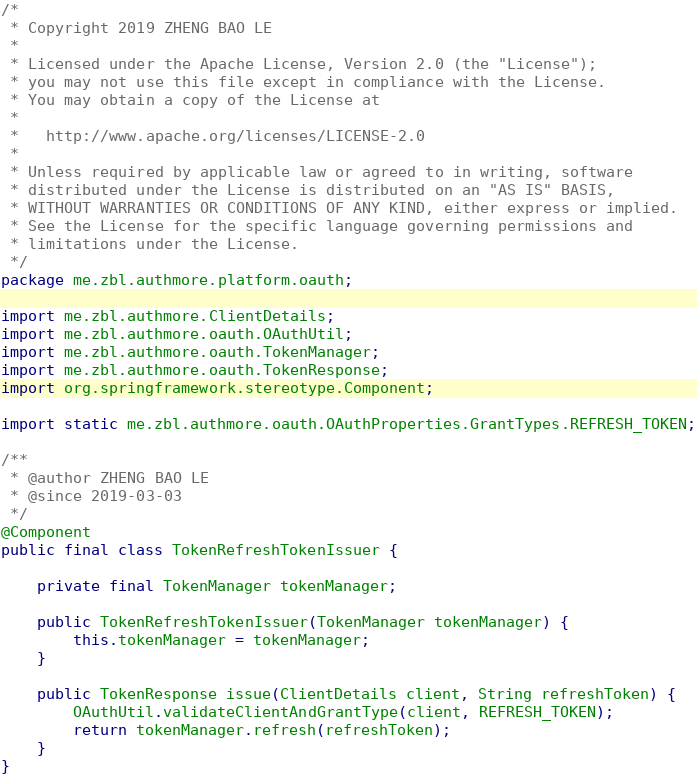<code> <loc_0><loc_0><loc_500><loc_500><_Java_>/*
 * Copyright 2019 ZHENG BAO LE
 *
 * Licensed under the Apache License, Version 2.0 (the "License");
 * you may not use this file except in compliance with the License.
 * You may obtain a copy of the License at
 *
 *   http://www.apache.org/licenses/LICENSE-2.0
 *
 * Unless required by applicable law or agreed to in writing, software
 * distributed under the License is distributed on an "AS IS" BASIS,
 * WITHOUT WARRANTIES OR CONDITIONS OF ANY KIND, either express or implied.
 * See the License for the specific language governing permissions and
 * limitations under the License.
 */
package me.zbl.authmore.platform.oauth;

import me.zbl.authmore.ClientDetails;
import me.zbl.authmore.oauth.OAuthUtil;
import me.zbl.authmore.oauth.TokenManager;
import me.zbl.authmore.oauth.TokenResponse;
import org.springframework.stereotype.Component;

import static me.zbl.authmore.oauth.OAuthProperties.GrantTypes.REFRESH_TOKEN;

/**
 * @author ZHENG BAO LE
 * @since 2019-03-03
 */
@Component
public final class TokenRefreshTokenIssuer {

    private final TokenManager tokenManager;

    public TokenRefreshTokenIssuer(TokenManager tokenManager) {
        this.tokenManager = tokenManager;
    }

    public TokenResponse issue(ClientDetails client, String refreshToken) {
        OAuthUtil.validateClientAndGrantType(client, REFRESH_TOKEN);
        return tokenManager.refresh(refreshToken);
    }
}
</code> 